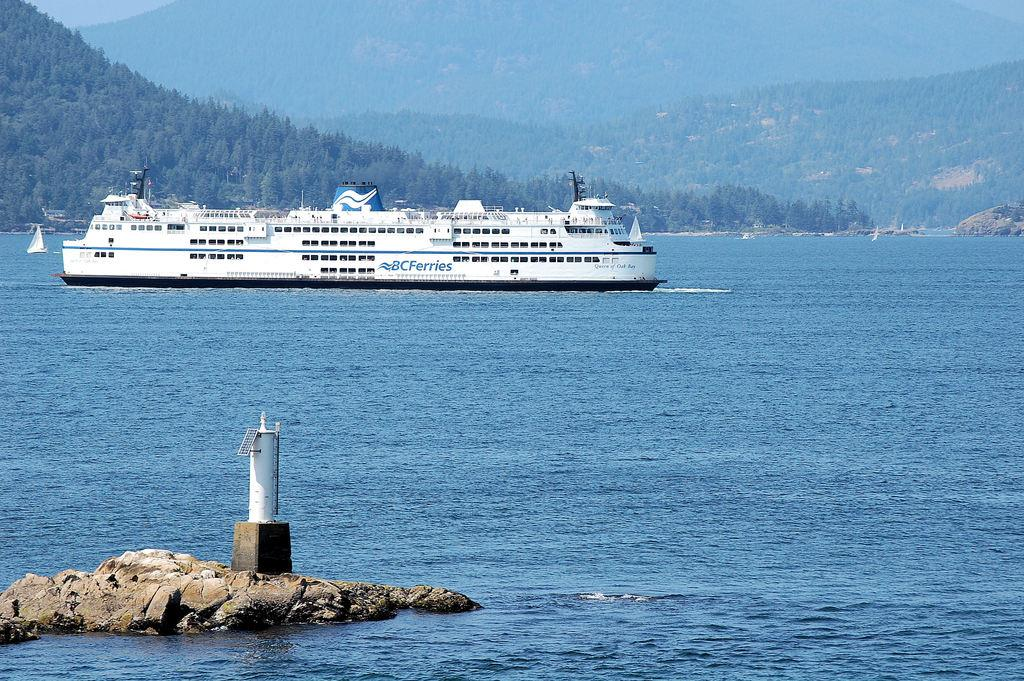What is the main subject in the water in the image? There is a ship in the water in the image. What structure can be seen in the image? There is a lighthouse in the image. What type of natural elements are present in the image? Stones and trees are visible in the image. Where is the playground located in the image? There is no playground present in the image. How many men are visible in the image? There is no mention of men in the provided facts, so we cannot determine their presence or number in the image. 